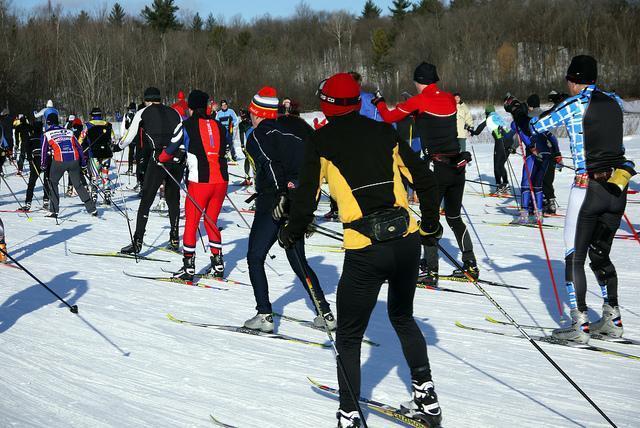How many people can be seen?
Give a very brief answer. 7. 